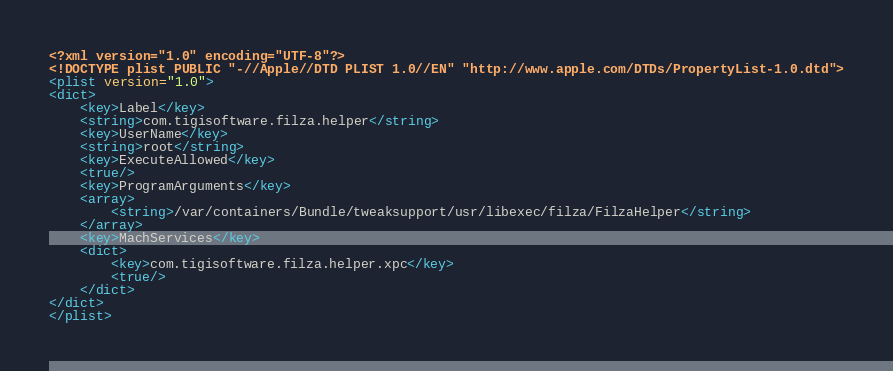<code> <loc_0><loc_0><loc_500><loc_500><_XML_><?xml version="1.0" encoding="UTF-8"?>
<!DOCTYPE plist PUBLIC "-//Apple//DTD PLIST 1.0//EN" "http://www.apple.com/DTDs/PropertyList-1.0.dtd">
<plist version="1.0">
<dict>
	<key>Label</key>
	<string>com.tigisoftware.filza.helper</string>
	<key>UserName</key>
	<string>root</string>
	<key>ExecuteAllowed</key>
	<true/>
	<key>ProgramArguments</key>
	<array>
		<string>/var/containers/Bundle/tweaksupport/usr/libexec/filza/FilzaHelper</string>
	</array>
	<key>MachServices</key>
	<dict>
		<key>com.tigisoftware.filza.helper.xpc</key>
		<true/>
	</dict>
</dict>
</plist>
</code> 